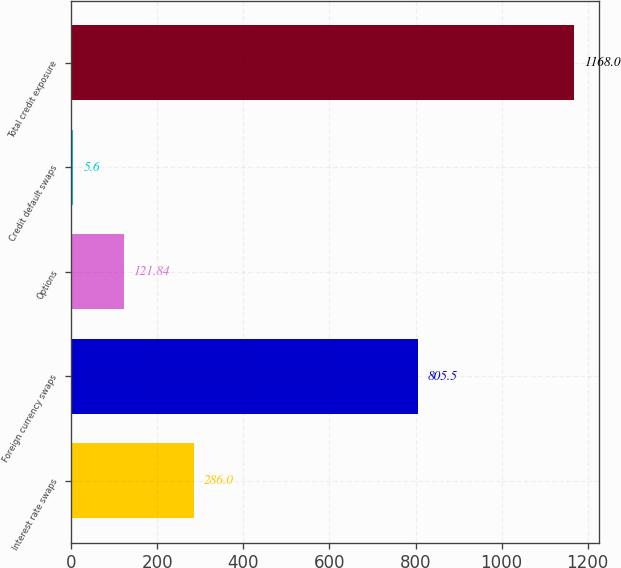Convert chart. <chart><loc_0><loc_0><loc_500><loc_500><bar_chart><fcel>Interest rate swaps<fcel>Foreign currency swaps<fcel>Options<fcel>Credit default swaps<fcel>Total credit exposure<nl><fcel>286<fcel>805.5<fcel>121.84<fcel>5.6<fcel>1168<nl></chart> 